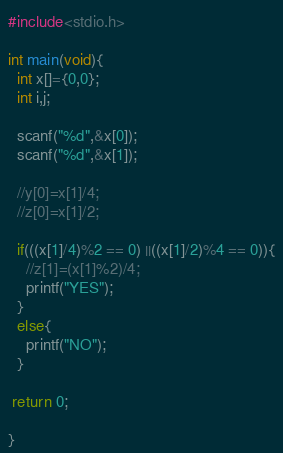<code> <loc_0><loc_0><loc_500><loc_500><_C_>#include<stdio.h>

int main(void){
  int x[]={0,0};
  int i,j;
  
  scanf("%d",&x[0]);
  scanf("%d",&x[1]);
  
  //y[0]=x[1]/4;
  //z[0]=x[1]/2;
  
  if(((x[1]/4)%2 == 0) ||((x[1]/2)%4 == 0)){
    //z[1]=(x[1]%2)/4;
    printf("YES");
  }
  else{
    printf("NO");
  }
  
 return 0;
  
}</code> 